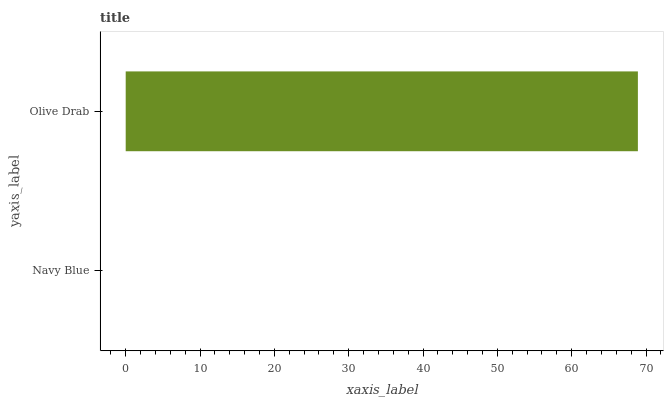Is Navy Blue the minimum?
Answer yes or no. Yes. Is Olive Drab the maximum?
Answer yes or no. Yes. Is Olive Drab the minimum?
Answer yes or no. No. Is Olive Drab greater than Navy Blue?
Answer yes or no. Yes. Is Navy Blue less than Olive Drab?
Answer yes or no. Yes. Is Navy Blue greater than Olive Drab?
Answer yes or no. No. Is Olive Drab less than Navy Blue?
Answer yes or no. No. Is Olive Drab the high median?
Answer yes or no. Yes. Is Navy Blue the low median?
Answer yes or no. Yes. Is Navy Blue the high median?
Answer yes or no. No. Is Olive Drab the low median?
Answer yes or no. No. 